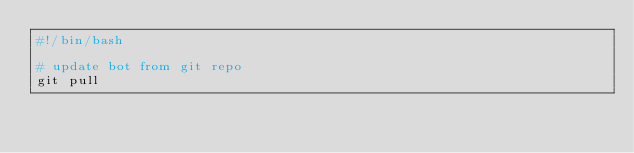Convert code to text. <code><loc_0><loc_0><loc_500><loc_500><_Bash_>#!/bin/bash

# update bot from git repo
git pull</code> 